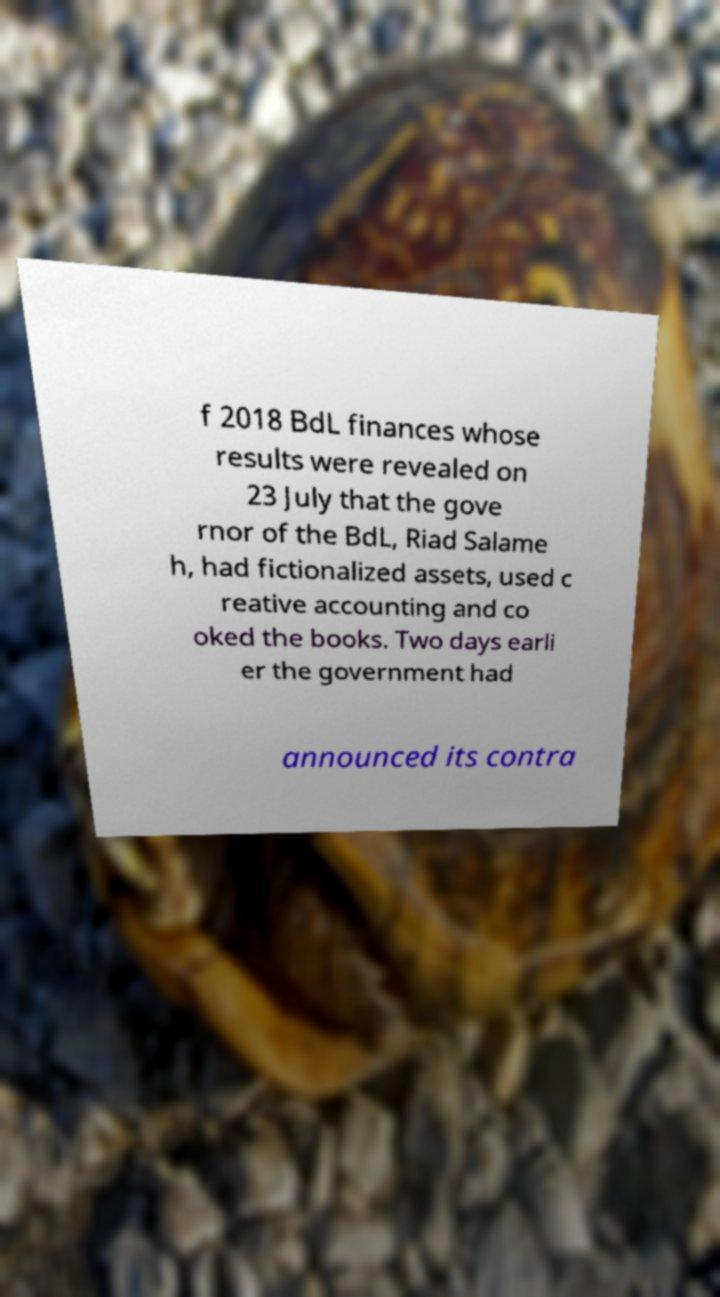There's text embedded in this image that I need extracted. Can you transcribe it verbatim? f 2018 BdL finances whose results were revealed on 23 July that the gove rnor of the BdL, Riad Salame h, had fictionalized assets, used c reative accounting and co oked the books. Two days earli er the government had announced its contra 